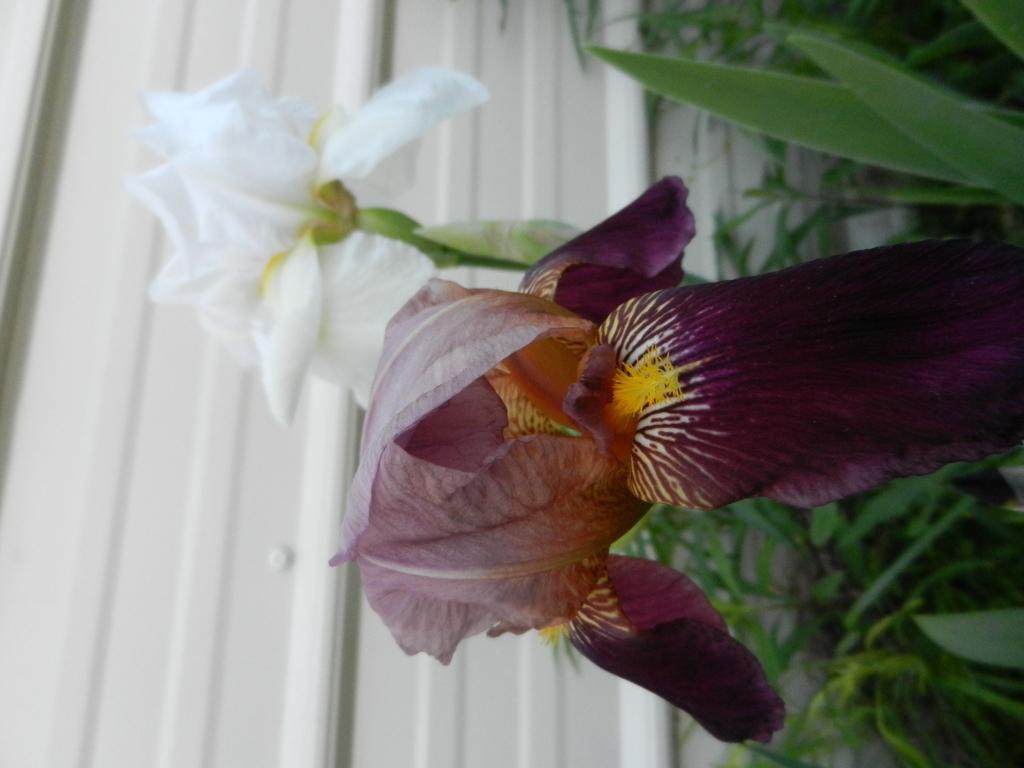How would you summarize this image in a sentence or two? On the right side, we see the plants which have flowers. These flowers are in white and dark purple color. In the background, we see a white wall. 